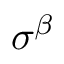Convert formula to latex. <formula><loc_0><loc_0><loc_500><loc_500>\sigma ^ { \beta }</formula> 